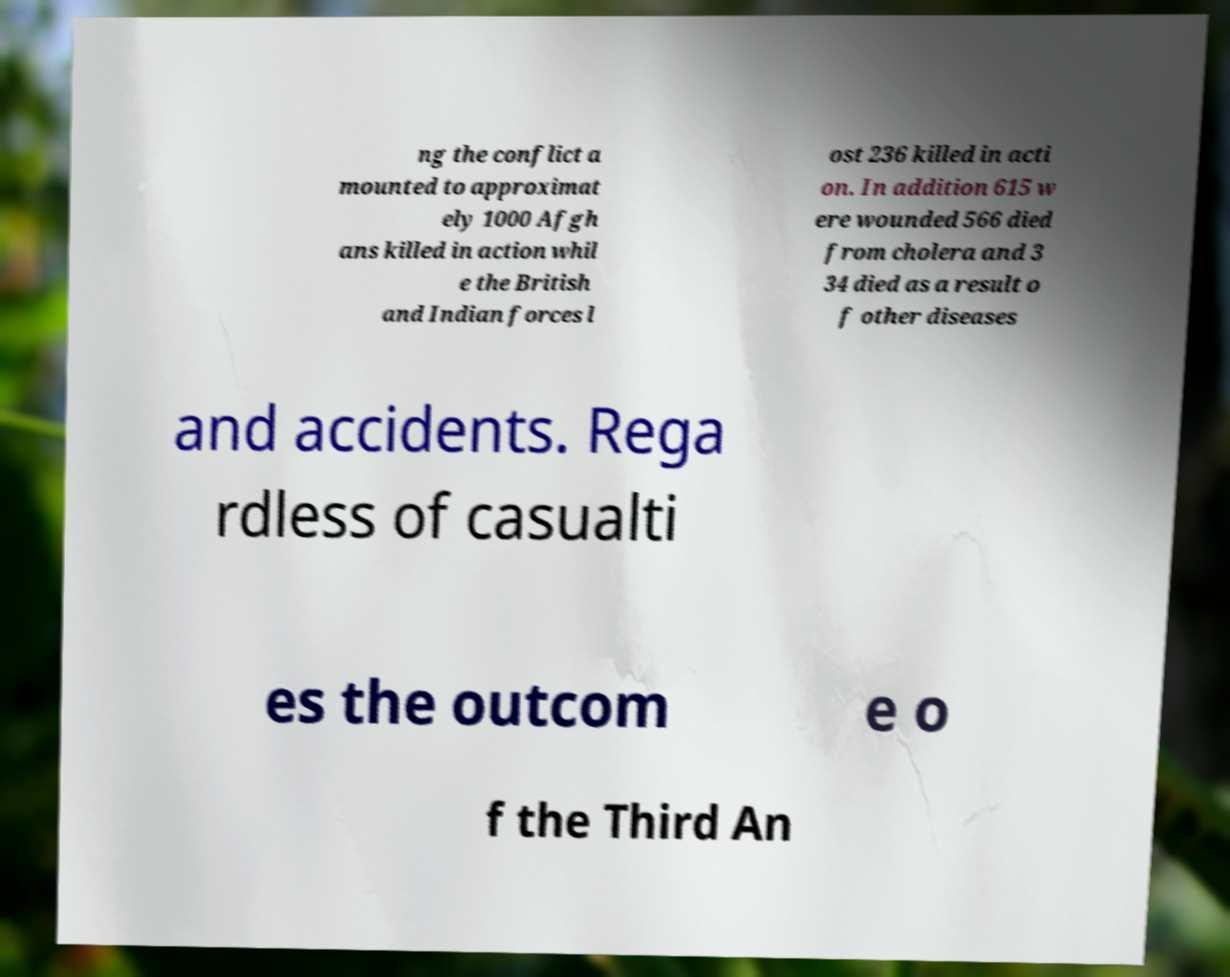For documentation purposes, I need the text within this image transcribed. Could you provide that? ng the conflict a mounted to approximat ely 1000 Afgh ans killed in action whil e the British and Indian forces l ost 236 killed in acti on. In addition 615 w ere wounded 566 died from cholera and 3 34 died as a result o f other diseases and accidents. Rega rdless of casualti es the outcom e o f the Third An 